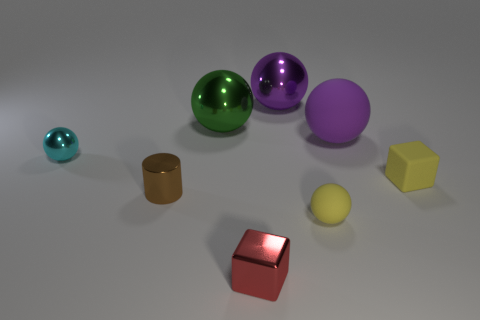There is a shiny sphere on the right side of the green shiny object; is its color the same as the ball that is left of the brown cylinder?
Keep it short and to the point. No. What number of things are either tiny shiny things or brown cylinders?
Your answer should be very brief. 3. What number of other things are there of the same shape as the purple metallic object?
Your response must be concise. 4. Is the material of the small yellow thing that is left of the tiny yellow rubber block the same as the red object in front of the cyan object?
Your answer should be compact. No. What shape is the shiny thing that is both on the right side of the green sphere and behind the large rubber thing?
Your response must be concise. Sphere. Is there anything else that has the same material as the small yellow block?
Provide a short and direct response. Yes. There is a sphere that is both on the right side of the red metal thing and in front of the purple rubber sphere; what is its material?
Provide a succinct answer. Rubber. There is a tiny brown object that is the same material as the small red object; what shape is it?
Give a very brief answer. Cylinder. Is there any other thing of the same color as the metallic cylinder?
Your response must be concise. No. Are there more tiny spheres behind the cyan sphere than objects?
Your answer should be very brief. No. 